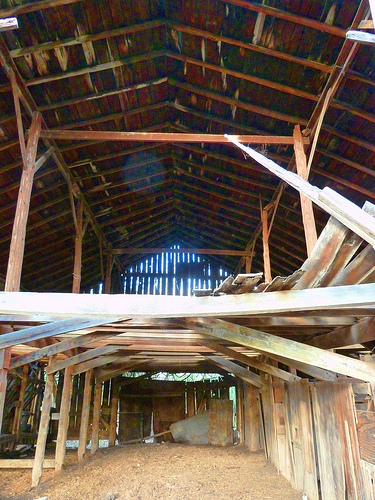<image>
Can you confirm if the beam is on the column? Yes. Looking at the image, I can see the beam is positioned on top of the column, with the column providing support. 